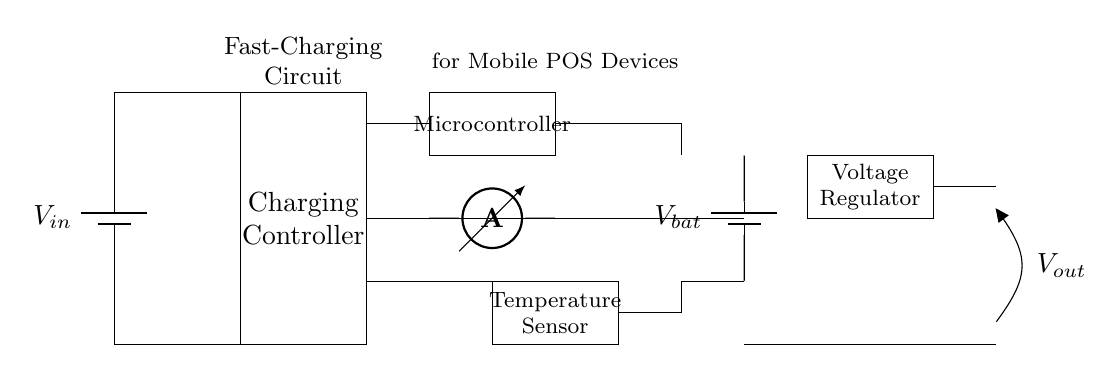What is the input voltage of the circuit? The input voltage is represented by \( V_{in} \), which connects from the battery to the charging controller.
Answer: \( V_{in} \) What component is used for temperature monitoring? The temperature sensor is the component responsible for monitoring temperature, indicated by its labeled rectangle in the diagram.
Answer: Temperature Sensor How many batteries are in the circuit? There are two batteries shown in the circuit; one connected to the input and another labeled as \( V_{bat} \) supplying the charging controller.
Answer: 2 What is the purpose of the microcontroller in this circuit? The microcontroller controls the fast-charging process, taking input from the current sensor and possibly the temperature sensor to regulate charging behavior.
Answer: Control fast-charging What is the output voltage of this circuit designated as? The circuit includes an output labeled \( V_{out} \), indicating the voltage output from the charging controller to the load or battery.
Answer: \( V_{out} \) Which component measures current in the circuit? The ammeter is the component used to measure current, connected between the charging controller and the voltage regulator to monitor current flow.
Answer: Ammeter What function does the voltage regulator serve? The voltage regulator is used to ensure a stable output voltage \( V_{out} \) regardless of variations in input or load conditions, maintaining consistent operation for the attached device.
Answer: Provide stable voltage 